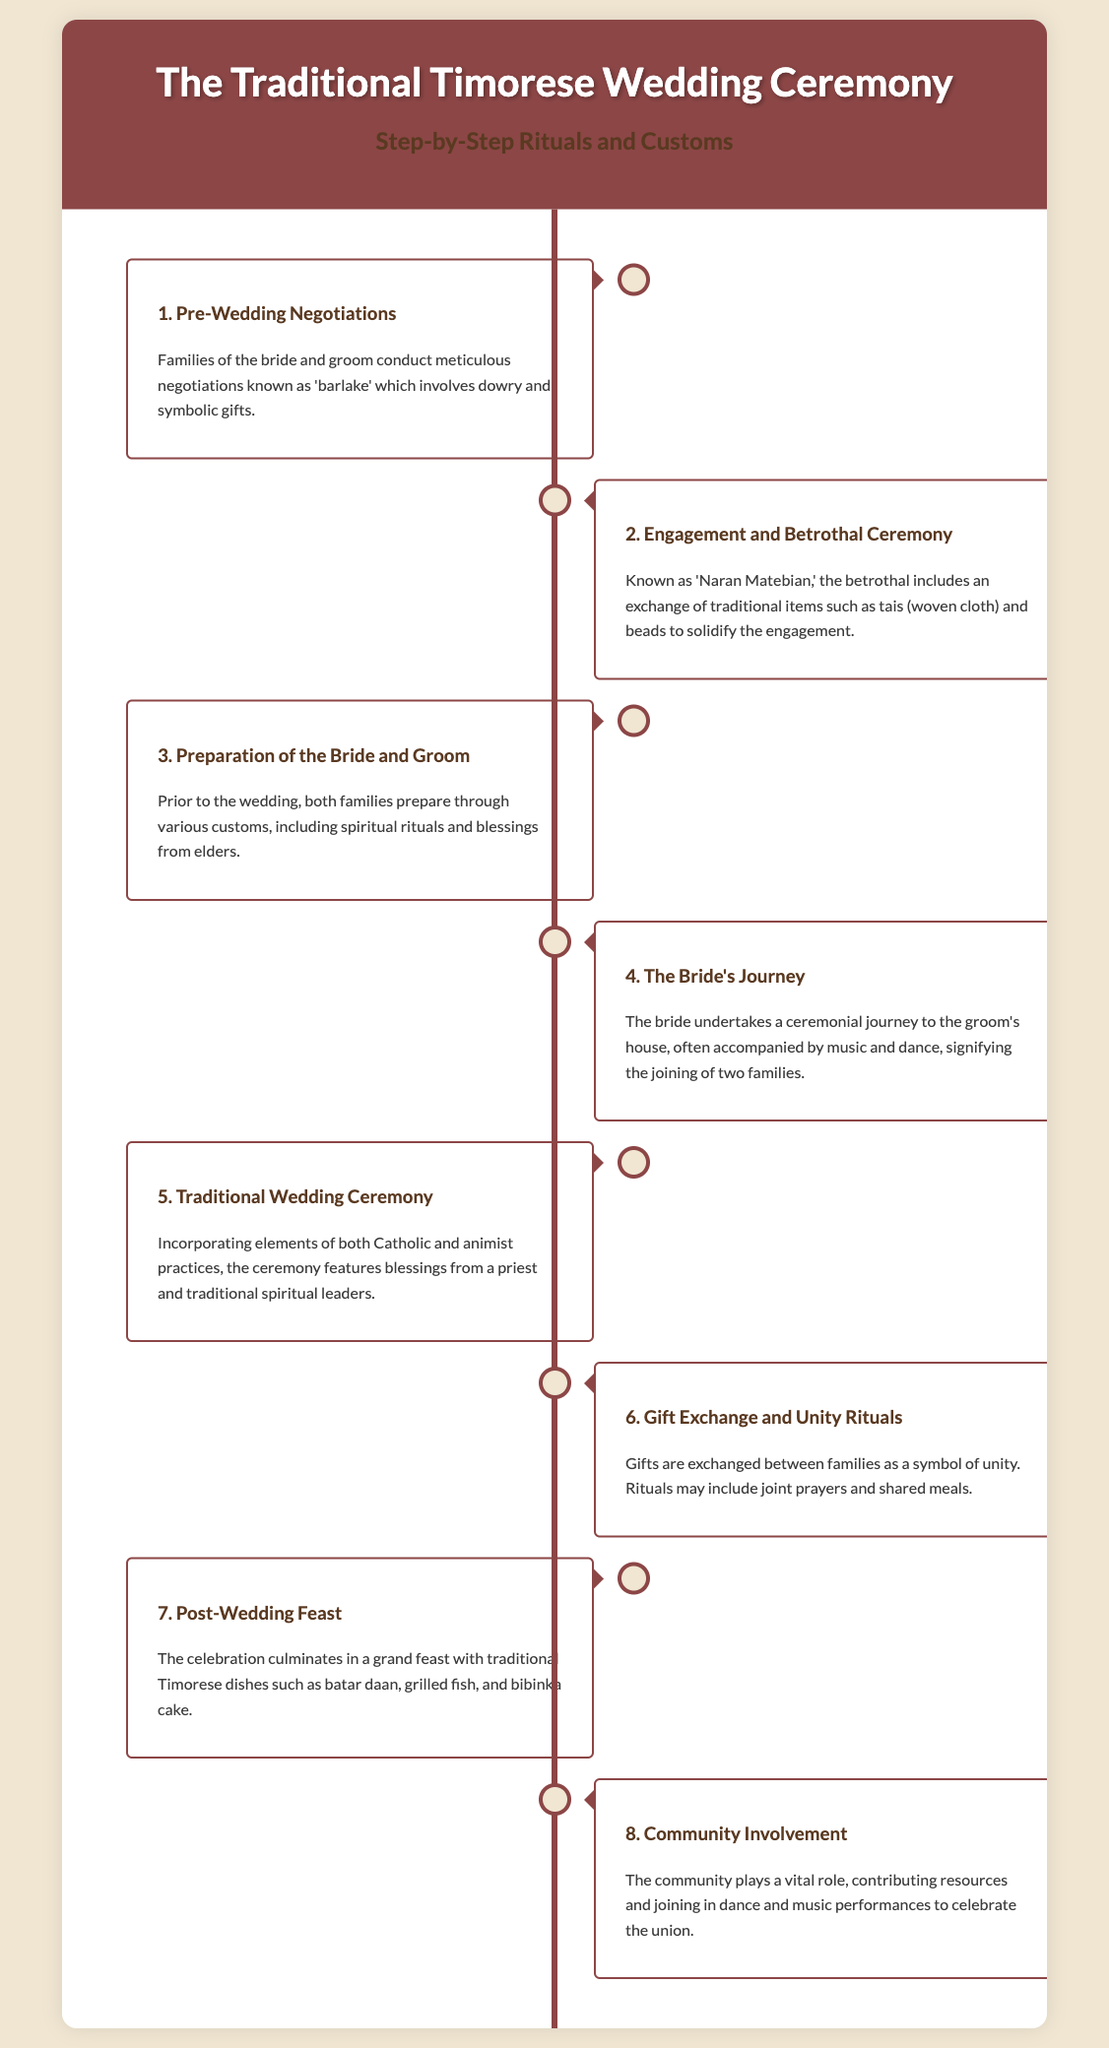What is the first step in the wedding ceremony? The first step in the wedding ceremony is "Pre-Wedding Negotiations," which involves meticulous discussions between families.
Answer: Pre-Wedding Negotiations What is 'Naran Matebian'? 'Naran Matebian' refers to the engagement and betrothal ceremony where traditional items are exchanged.
Answer: Engagement and Betrothal Ceremony What do families exchange during Step 6? In Step 6, families exchange gifts to symbolize unity and participate in rituals like joint prayers.
Answer: Gifts Which dish is mentioned in the post-wedding feast? The document mentions several dishes in the post-wedding feast, including batar daan.
Answer: Batar daan How many steps are detailed in the infographic? The document outlines a total of eight steps in the traditional wedding ceremony.
Answer: Eight What role does the community play in the ceremony? The community contributes resources and joins in performances to celebrate the wedding union.
Answer: Community involvement What is prepared for the bride and groom prior to the wedding? Families prepare through various customs, including spiritual rituals and blessings from elders before the wedding.
Answer: Spiritual rituals and blessings What happens during the bride's journey? The bride undertakes a ceremonial journey to the groom's house, signifying the joining of two families.
Answer: Ceremonial journey 